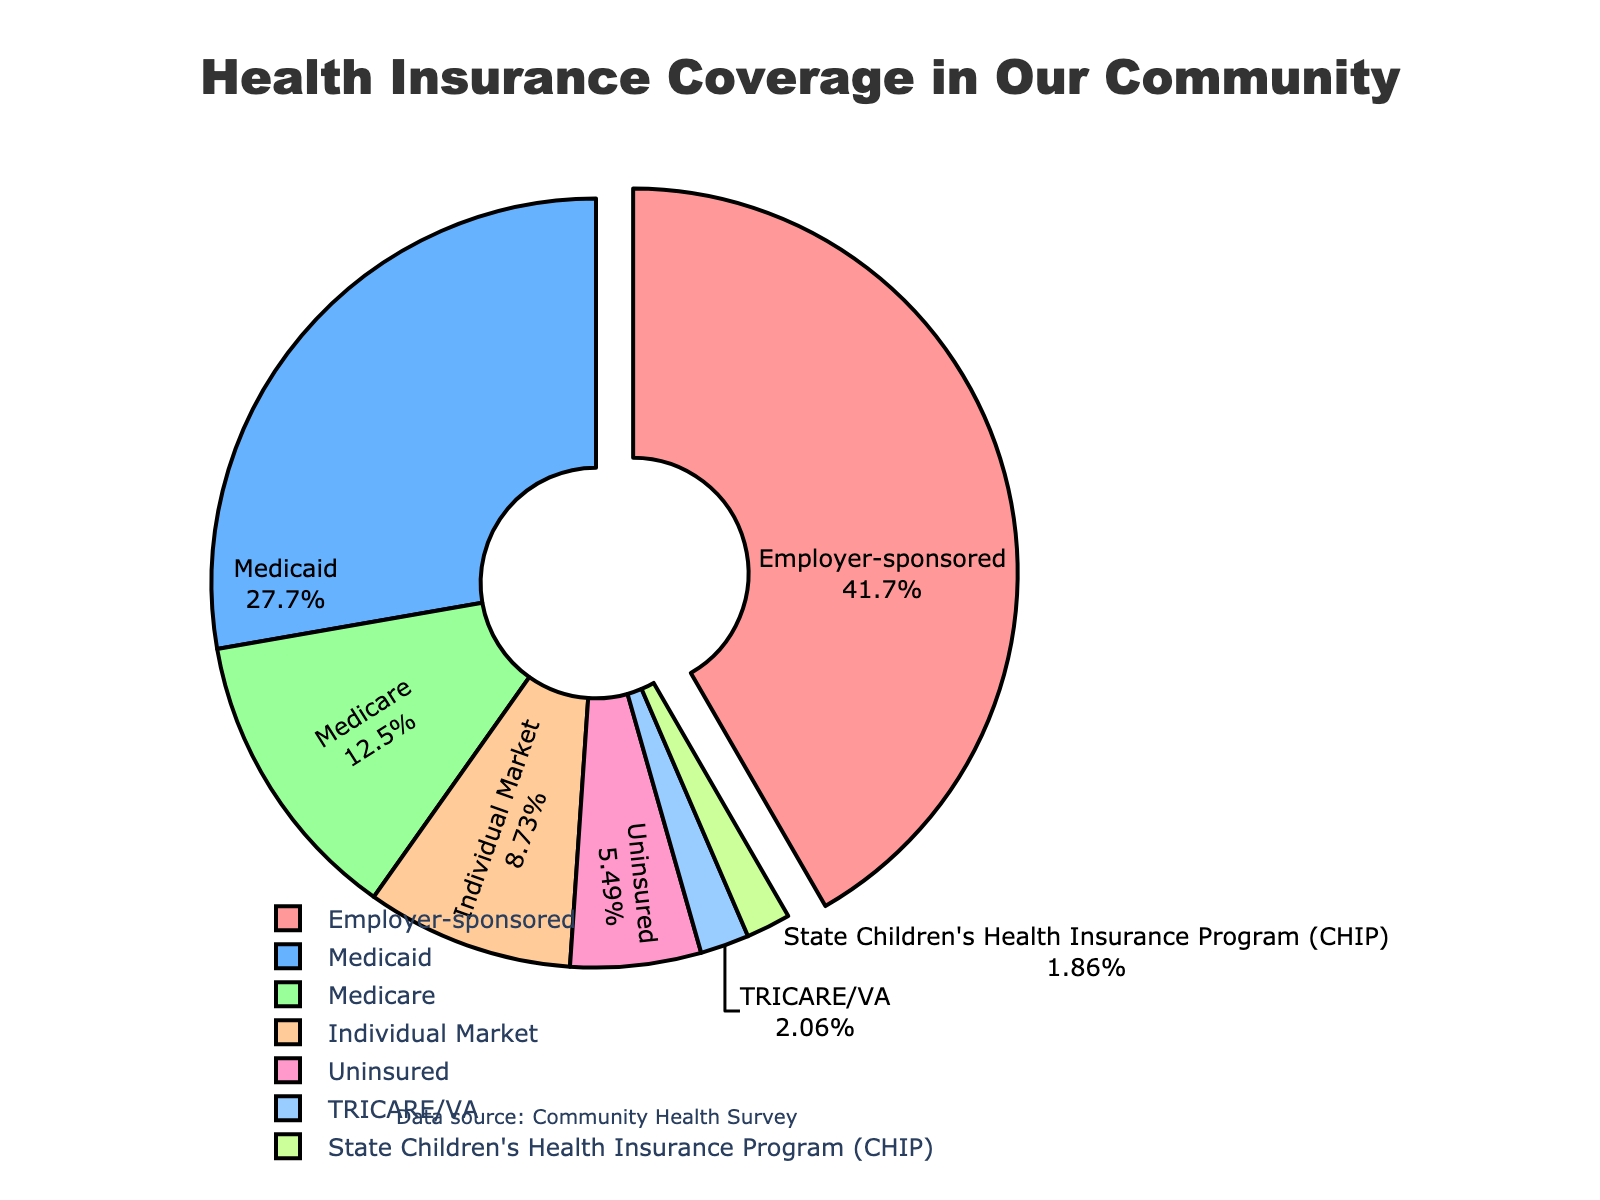What type of health insurance covers the largest percentage of community members? The largest wedge in the pie chart indicates the category with the highest percentage. The piece of the pie that's pulled out slightly is labeled "Employer-sponsored" with 42.5%.
Answer: Employer-sponsored Which two insurance types cover similar percentages of community members? By visually comparing the sizes of the wedges and their percentages, "TRICARE/VA" covers 2.1% and "State Children's Health Insurance Program (CHIP)" covers 1.9%. These percentages are closest to each other.
Answer: TRICARE/VA and State Children's Health Insurance Program (CHIP) How much more percentage is covered by Medicaid compared to Medicare? Medicaid covers 28.3%, and Medicare covers 12.7%. The difference between these two percentages can be calculated as 28.3% - 12.7% = 15.6%.
Answer: 15.6% What is the combined percentage of community members covered by Individual Market and Uninsured? Individual Market covers 8.9%, and Uninsured covers 5.6%. Adding these together, we get 8.9% + 5.6% = 14.5%.
Answer: 14.5% Which insurance type is represented by the light green color? By observing the colors associated with each segment of the pie chart, the light green color corresponds to "Medicaid".
Answer: Medicaid If the sum of percentages covered by Medicare and Employer-sponsored were to be divided equally between these categories, what would the new percentage for each be? Medicare covers 12.7% and Employer-sponsored covers 42.5%. Adding these together results in 12.7% + 42.5% = 55.2%. Dividing this equally between the two yields 55.2% / 2 = 27.6% for each.
Answer: 27.6% Which insurance type covers less than 10% but more than 5% of community members? Examining the percentages in the chart, "Individual Market" has 8.9%, which fits within the range of greater than 5% but less than 10%.
Answer: Individual Market What is the difference in the percentage coverage between the second and third largest insurance types? The second largest is Medicaid with 28.3%, and the third largest is Medicare with 12.7%. The difference is 28.3% - 12.7% = 15.6%.
Answer: 15.6% How much more percentage coverage does Employer-sponsored insurance have over Uninsured? Employer-sponsored covers 42.5%, and Uninsured covers 5.6%. The difference is 42.5% - 5.6% = 36.9%.
Answer: 36.9% What percentage of community members are covered by government programs (Medicaid, Medicare, TRICARE/VA, CHIP)? The percentages for Medicaid, Medicare, TRICARE/VA, and CHIP are 28.3%, 12.7%, 2.1%, and 1.9%, respectively. Summing these, 28.3% + 12.7% + 2.1% + 1.9% = 45%.
Answer: 45% 